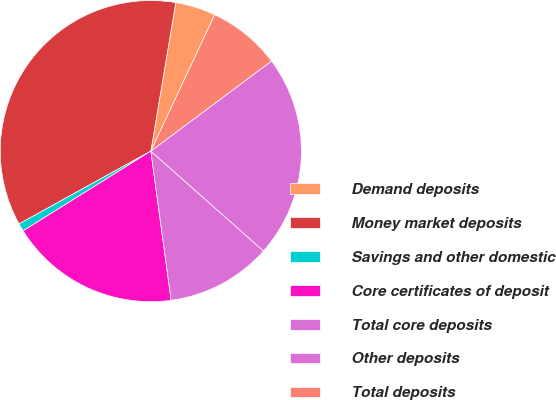Convert chart to OTSL. <chart><loc_0><loc_0><loc_500><loc_500><pie_chart><fcel>Demand deposits<fcel>Money market deposits<fcel>Savings and other domestic<fcel>Core certificates of deposit<fcel>Total core deposits<fcel>Other deposits<fcel>Total deposits<nl><fcel>4.33%<fcel>35.68%<fcel>0.85%<fcel>18.27%<fcel>11.3%<fcel>21.75%<fcel>7.82%<nl></chart> 